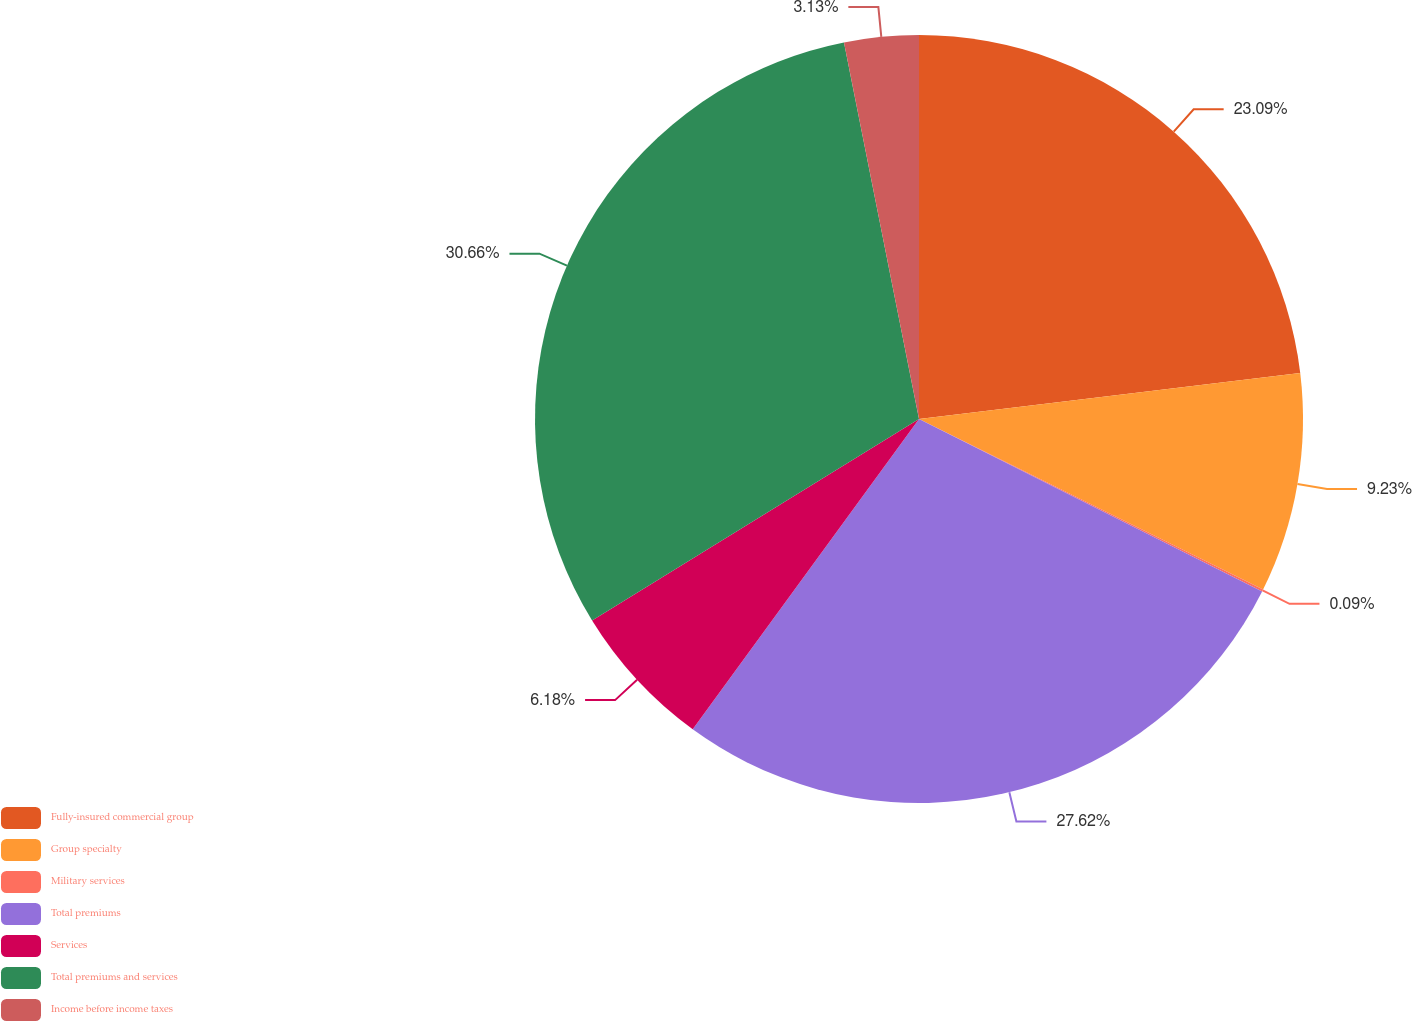Convert chart to OTSL. <chart><loc_0><loc_0><loc_500><loc_500><pie_chart><fcel>Fully-insured commercial group<fcel>Group specialty<fcel>Military services<fcel>Total premiums<fcel>Services<fcel>Total premiums and services<fcel>Income before income taxes<nl><fcel>23.09%<fcel>9.23%<fcel>0.09%<fcel>27.62%<fcel>6.18%<fcel>30.66%<fcel>3.13%<nl></chart> 